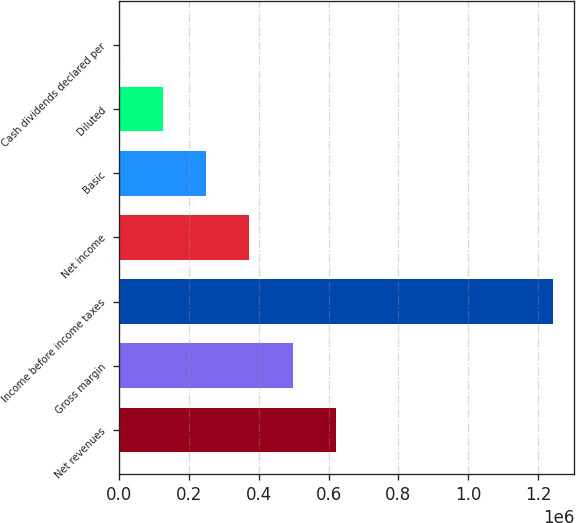<chart> <loc_0><loc_0><loc_500><loc_500><bar_chart><fcel>Net revenues<fcel>Gross margin<fcel>Income before income taxes<fcel>Net income<fcel>Basic<fcel>Diluted<fcel>Cash dividends declared per<nl><fcel>620741<fcel>496592<fcel>1.24148e+06<fcel>372444<fcel>248296<fcel>124148<fcel>0.05<nl></chart> 